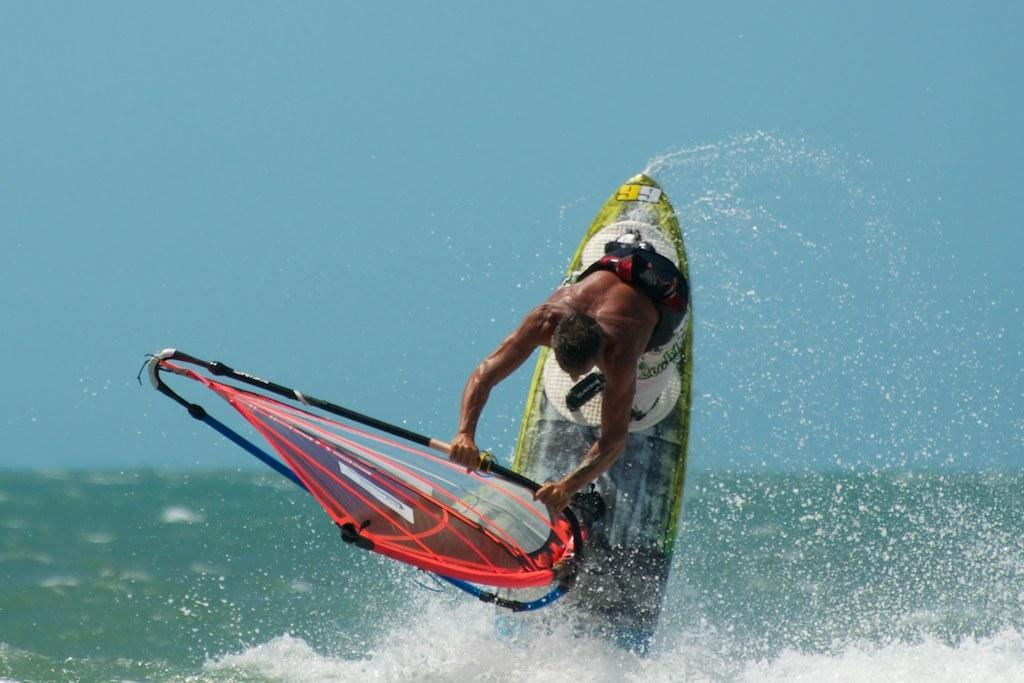Who is in the image? There is a person in the image. What is the person holding? The person is holding a surfboard. Can you describe the surfboard? The surfboard is colorful. Where is the person located in the image? The person is in the water. What can be seen in the background of the image? The background of the image includes a blue sky. What type of humor is being displayed by the channel in the image? There is no channel present in the image, and therefore no humor can be observed. 